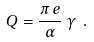<formula> <loc_0><loc_0><loc_500><loc_500>Q = \frac { \pi \, e } { \alpha } \, \gamma \ .</formula> 